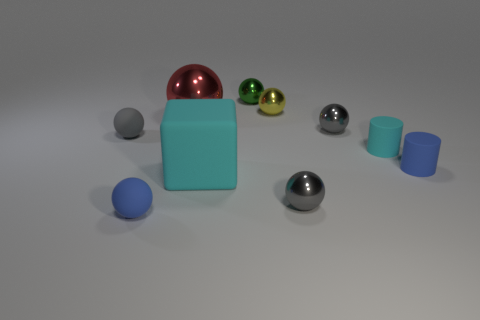How many gray balls must be subtracted to get 1 gray balls? 2 Subtract all blue spheres. How many spheres are left? 6 Subtract all yellow cylinders. How many gray spheres are left? 3 Subtract 3 balls. How many balls are left? 4 Subtract all green balls. How many balls are left? 6 Subtract all cylinders. How many objects are left? 8 Add 1 small green metal balls. How many small green metal balls exist? 2 Subtract 1 cyan cylinders. How many objects are left? 9 Subtract all brown cylinders. Subtract all yellow spheres. How many cylinders are left? 2 Subtract all blue metallic blocks. Subtract all small gray matte balls. How many objects are left? 9 